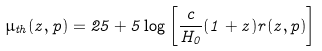<formula> <loc_0><loc_0><loc_500><loc_500>\mu _ { t h } ( z , { p } ) = 2 5 + 5 \log { \left [ \frac { c } { H _ { 0 } } ( 1 + z ) r ( z , { p } ) \right ] }</formula> 